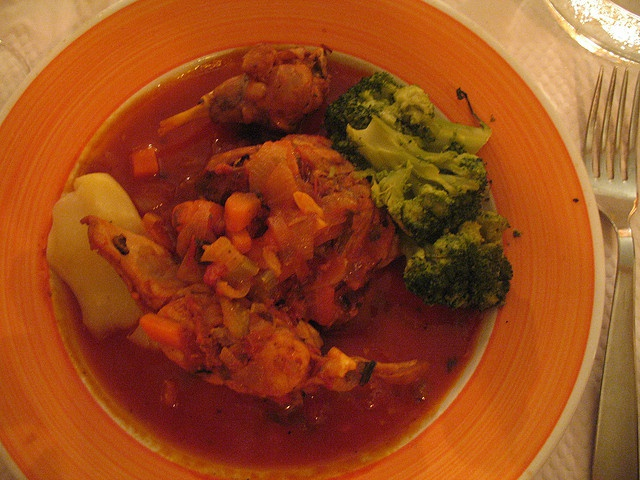Describe the objects in this image and their specific colors. I can see dining table in brown, maroon, red, and tan tones, bowl in red, maroon, and salmon tones, broccoli in salmon, black, olive, and maroon tones, fork in salmon, olive, gray, and tan tones, and carrot in salmon, brown, maroon, and red tones in this image. 